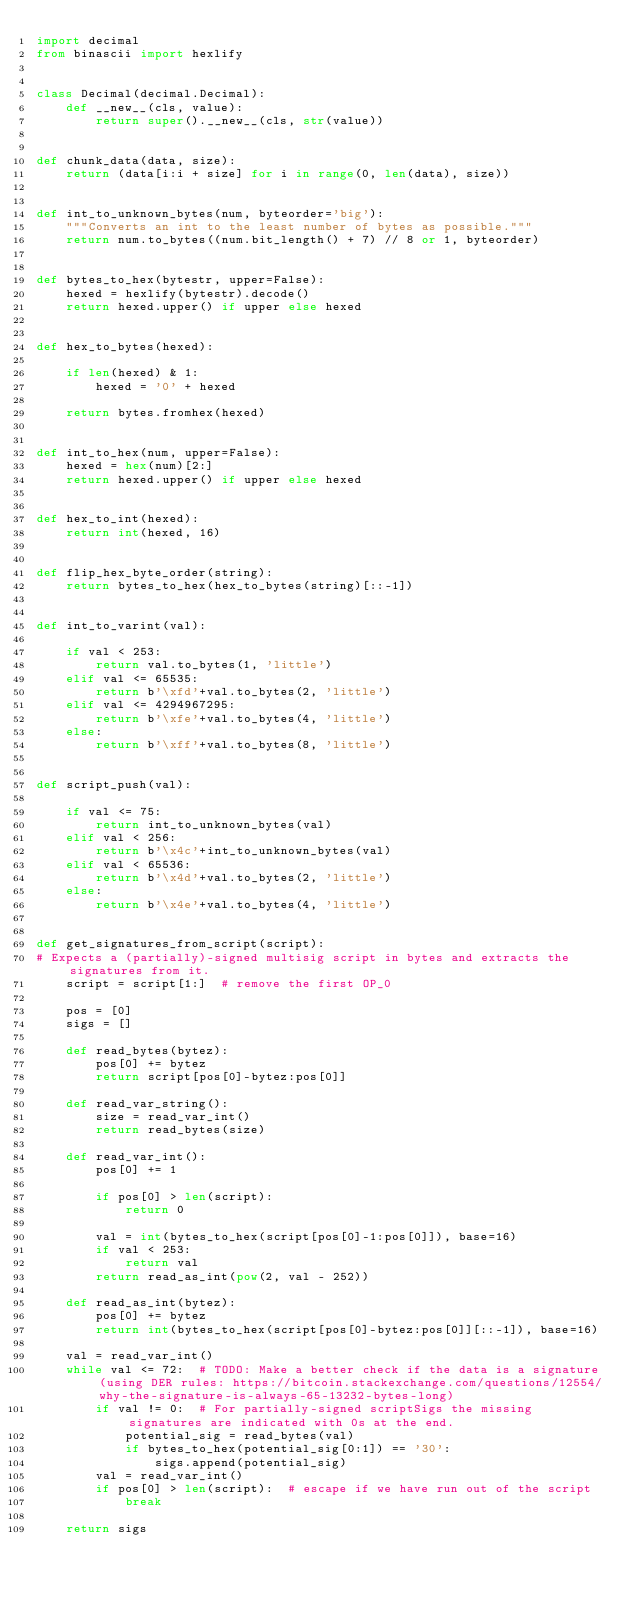<code> <loc_0><loc_0><loc_500><loc_500><_Python_>import decimal
from binascii import hexlify


class Decimal(decimal.Decimal):
    def __new__(cls, value):
        return super().__new__(cls, str(value))


def chunk_data(data, size):
    return (data[i:i + size] for i in range(0, len(data), size))


def int_to_unknown_bytes(num, byteorder='big'):
    """Converts an int to the least number of bytes as possible."""
    return num.to_bytes((num.bit_length() + 7) // 8 or 1, byteorder)


def bytes_to_hex(bytestr, upper=False):
    hexed = hexlify(bytestr).decode()
    return hexed.upper() if upper else hexed


def hex_to_bytes(hexed):

    if len(hexed) & 1:
        hexed = '0' + hexed

    return bytes.fromhex(hexed)


def int_to_hex(num, upper=False):
    hexed = hex(num)[2:]
    return hexed.upper() if upper else hexed


def hex_to_int(hexed):
    return int(hexed, 16)


def flip_hex_byte_order(string):
    return bytes_to_hex(hex_to_bytes(string)[::-1])


def int_to_varint(val):

    if val < 253:
        return val.to_bytes(1, 'little')
    elif val <= 65535:
        return b'\xfd'+val.to_bytes(2, 'little')
    elif val <= 4294967295:
        return b'\xfe'+val.to_bytes(4, 'little')
    else:
        return b'\xff'+val.to_bytes(8, 'little')


def script_push(val):

    if val <= 75:
        return int_to_unknown_bytes(val)
    elif val < 256:
        return b'\x4c'+int_to_unknown_bytes(val)
    elif val < 65536:
        return b'\x4d'+val.to_bytes(2, 'little')
    else:
        return b'\x4e'+val.to_bytes(4, 'little')


def get_signatures_from_script(script):
# Expects a (partially)-signed multisig script in bytes and extracts the signatures from it.
    script = script[1:]  # remove the first OP_0

    pos = [0]
    sigs = []

    def read_bytes(bytez):
        pos[0] += bytez
        return script[pos[0]-bytez:pos[0]]

    def read_var_string():
        size = read_var_int()
        return read_bytes(size)

    def read_var_int():
        pos[0] += 1

        if pos[0] > len(script):
            return 0

        val = int(bytes_to_hex(script[pos[0]-1:pos[0]]), base=16)
        if val < 253:
            return val
        return read_as_int(pow(2, val - 252))

    def read_as_int(bytez):
        pos[0] += bytez
        return int(bytes_to_hex(script[pos[0]-bytez:pos[0]][::-1]), base=16)

    val = read_var_int()
    while val <= 72:  # TODO: Make a better check if the data is a signature (using DER rules: https://bitcoin.stackexchange.com/questions/12554/why-the-signature-is-always-65-13232-bytes-long)
        if val != 0:  # For partially-signed scriptSigs the missing signatures are indicated with 0s at the end.
            potential_sig = read_bytes(val)
            if bytes_to_hex(potential_sig[0:1]) == '30':
                sigs.append(potential_sig)
        val = read_var_int()
        if pos[0] > len(script):  # escape if we have run out of the script
            break

    return sigs
</code> 